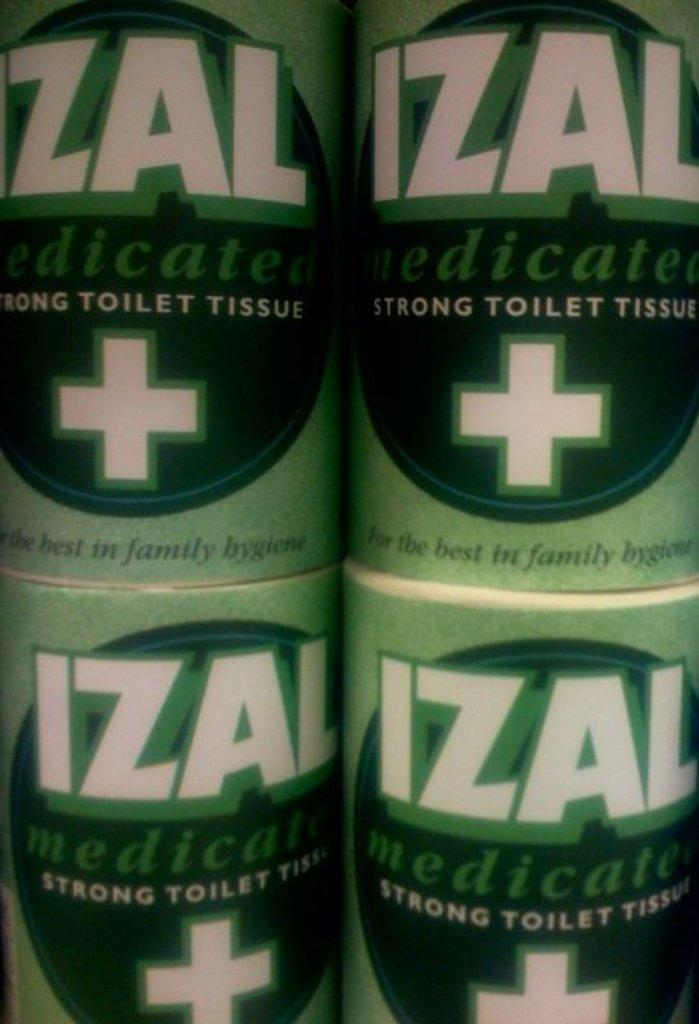Provide a one-sentence caption for the provided image. Four rolls of Izal toilet tissue with a white plus sign on the label. 